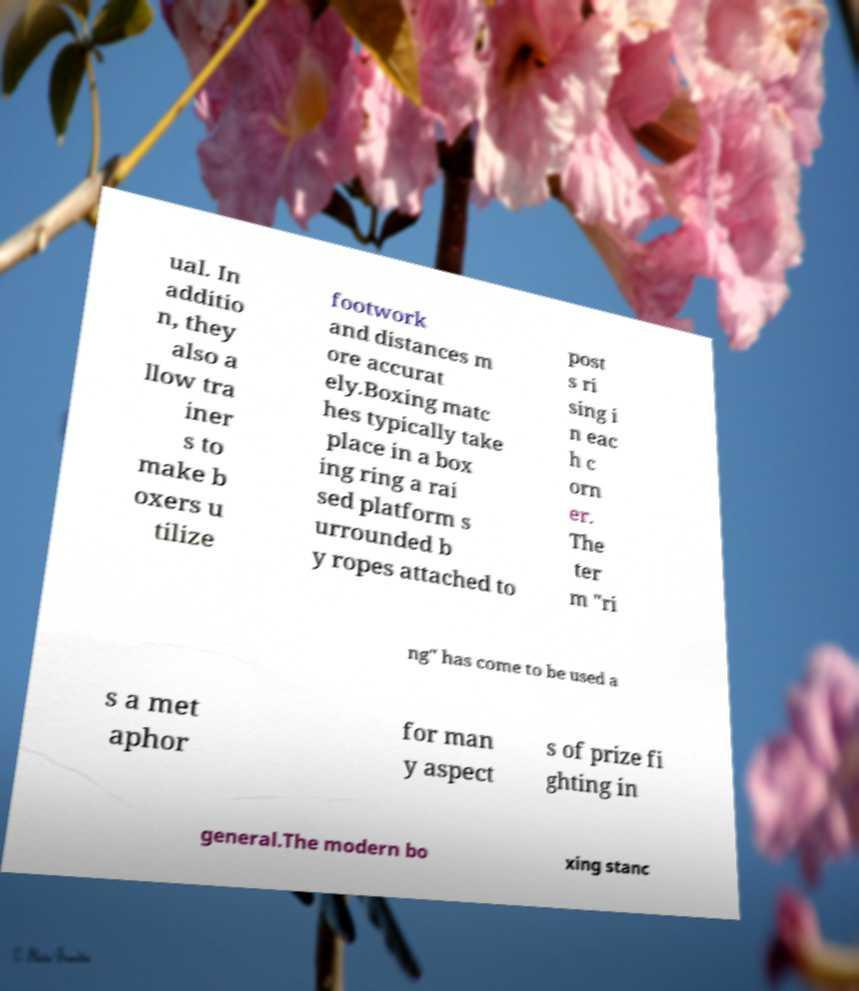What messages or text are displayed in this image? I need them in a readable, typed format. ual. In additio n, they also a llow tra iner s to make b oxers u tilize footwork and distances m ore accurat ely.Boxing matc hes typically take place in a box ing ring a rai sed platform s urrounded b y ropes attached to post s ri sing i n eac h c orn er. The ter m "ri ng" has come to be used a s a met aphor for man y aspect s of prize fi ghting in general.The modern bo xing stanc 